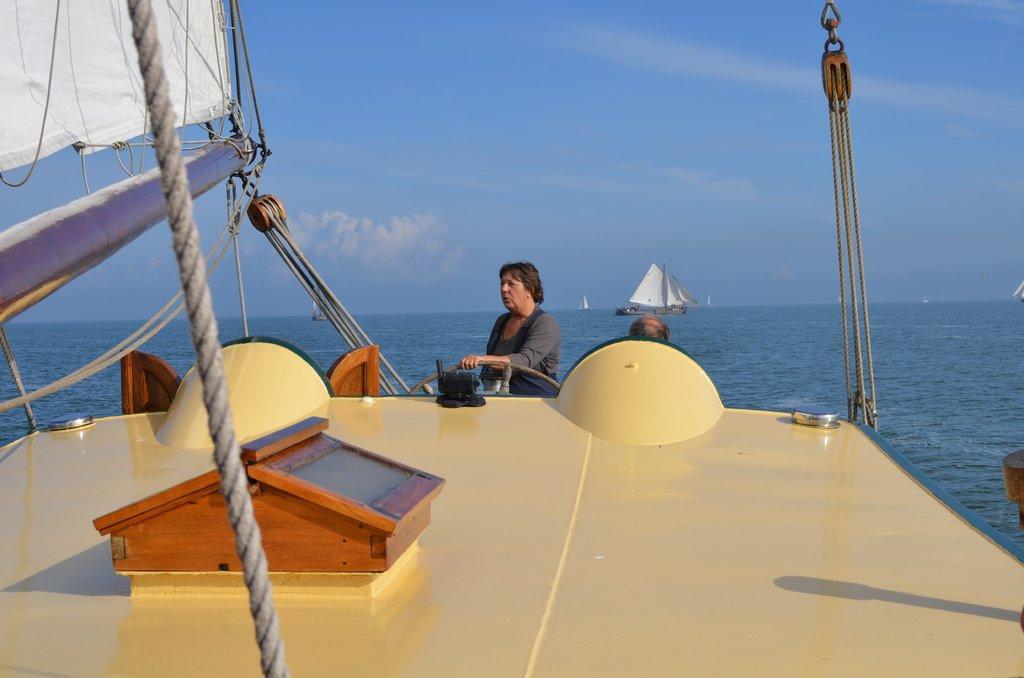How would you summarize this image in a sentence or two? Here in this picture in the front we can see a boat present in the water and in the middle we can see a woman riding the boat and in the far we can see other boats also present and we can see ropes present on the boat and we can see clouds in the sky. 